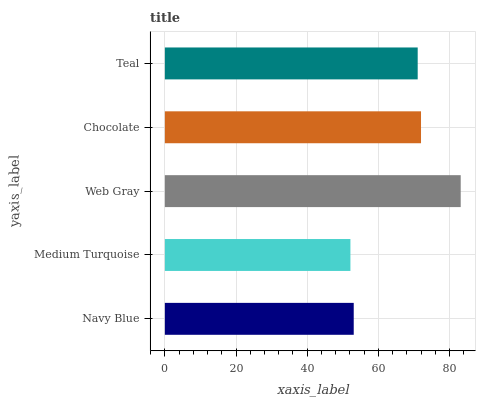Is Medium Turquoise the minimum?
Answer yes or no. Yes. Is Web Gray the maximum?
Answer yes or no. Yes. Is Web Gray the minimum?
Answer yes or no. No. Is Medium Turquoise the maximum?
Answer yes or no. No. Is Web Gray greater than Medium Turquoise?
Answer yes or no. Yes. Is Medium Turquoise less than Web Gray?
Answer yes or no. Yes. Is Medium Turquoise greater than Web Gray?
Answer yes or no. No. Is Web Gray less than Medium Turquoise?
Answer yes or no. No. Is Teal the high median?
Answer yes or no. Yes. Is Teal the low median?
Answer yes or no. Yes. Is Chocolate the high median?
Answer yes or no. No. Is Web Gray the low median?
Answer yes or no. No. 